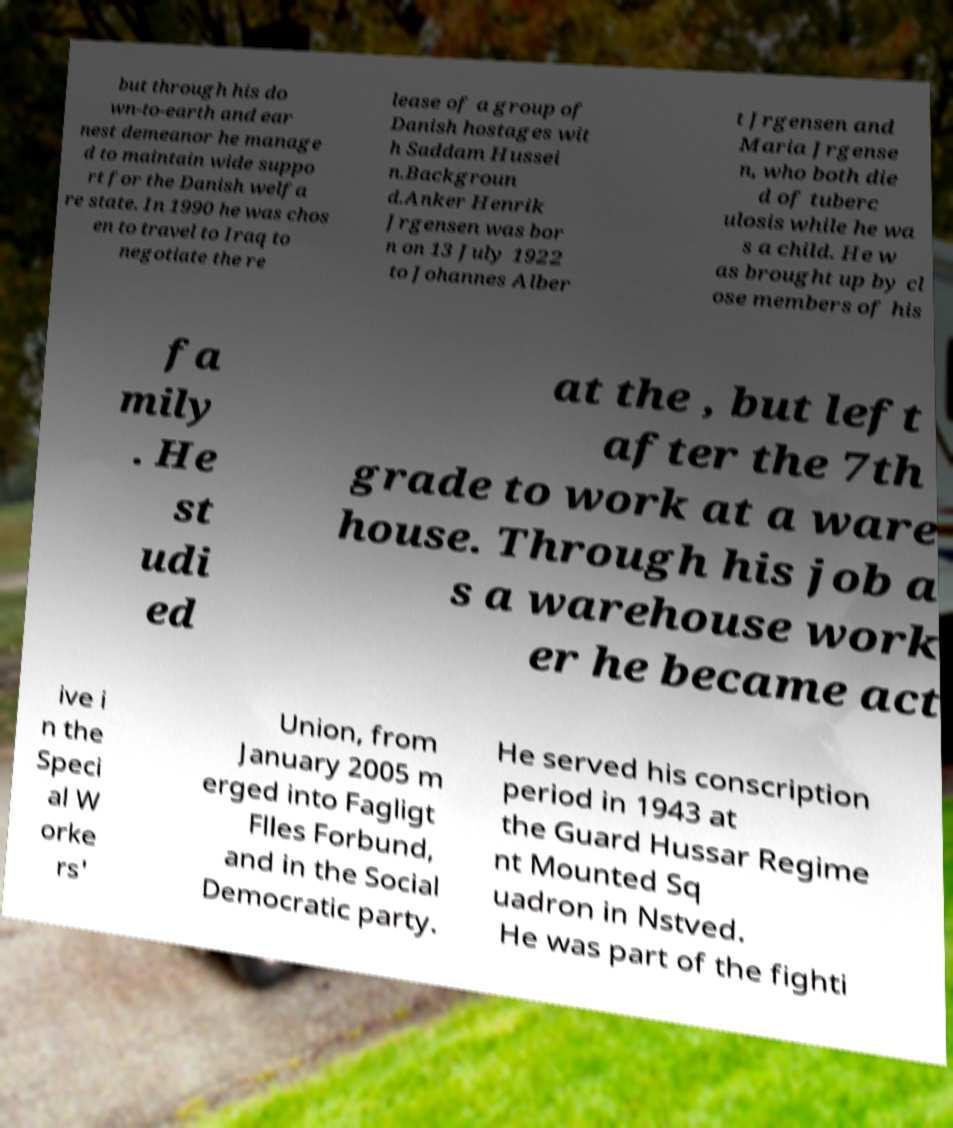Can you accurately transcribe the text from the provided image for me? but through his do wn-to-earth and ear nest demeanor he manage d to maintain wide suppo rt for the Danish welfa re state. In 1990 he was chos en to travel to Iraq to negotiate the re lease of a group of Danish hostages wit h Saddam Hussei n.Backgroun d.Anker Henrik Jrgensen was bor n on 13 July 1922 to Johannes Alber t Jrgensen and Maria Jrgense n, who both die d of tuberc ulosis while he wa s a child. He w as brought up by cl ose members of his fa mily . He st udi ed at the , but left after the 7th grade to work at a ware house. Through his job a s a warehouse work er he became act ive i n the Speci al W orke rs' Union, from January 2005 m erged into Fagligt Flles Forbund, and in the Social Democratic party. He served his conscription period in 1943 at the Guard Hussar Regime nt Mounted Sq uadron in Nstved. He was part of the fighti 